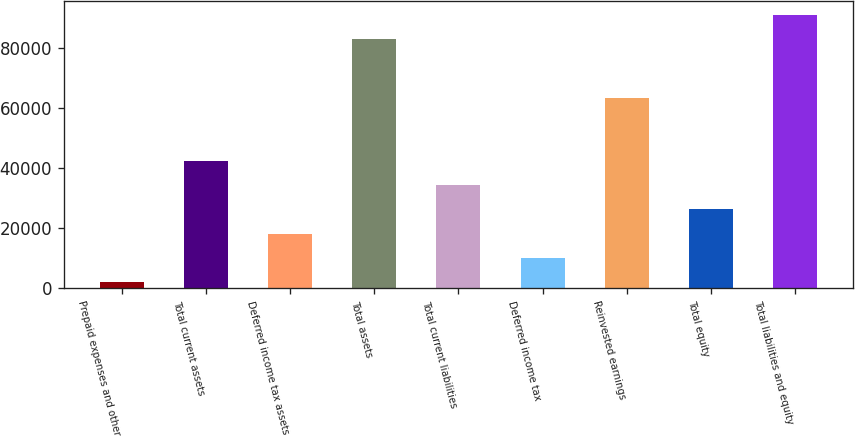<chart> <loc_0><loc_0><loc_500><loc_500><bar_chart><fcel>Prepaid expenses and other<fcel>Total current assets<fcel>Deferred income tax assets<fcel>Total assets<fcel>Total current liabilities<fcel>Deferred income tax<fcel>Reinvested earnings<fcel>Total equity<fcel>Total liabilities and equity<nl><fcel>1970<fcel>42541<fcel>18198.4<fcel>83112<fcel>34426.8<fcel>10084.2<fcel>63480<fcel>26312.6<fcel>91226.2<nl></chart> 